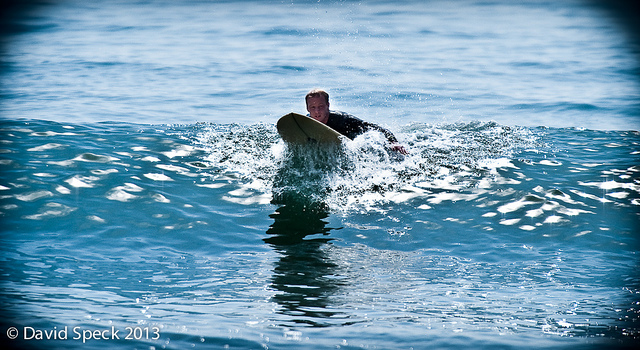<image>What is the foamy stuff called? I'm not sure what the foamy stuff is called. It could be surf, waves, skin, white caps, sea foam, or suds. What is the foamy stuff called? I don't know what the foamy stuff is called. It can be either surf, waves, skin, white caps, sea foam or suds. 